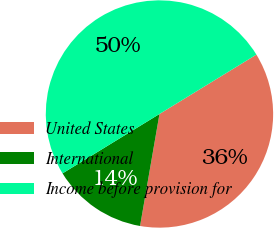Convert chart. <chart><loc_0><loc_0><loc_500><loc_500><pie_chart><fcel>United States<fcel>International<fcel>Income before provision for<nl><fcel>36.48%<fcel>13.52%<fcel>50.0%<nl></chart> 